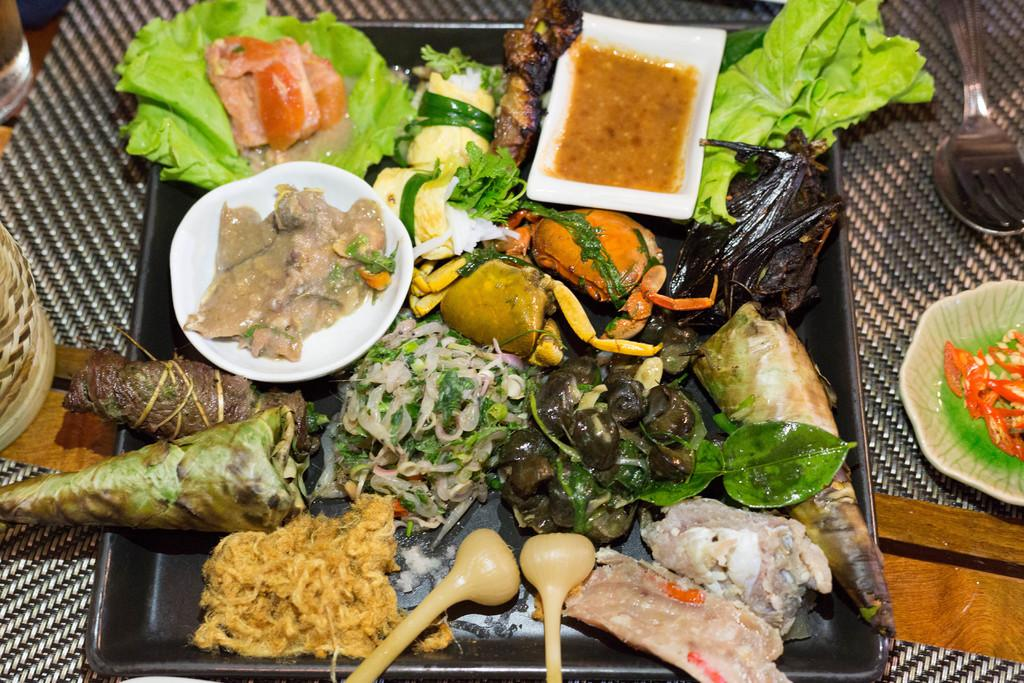What type of objects can be seen in the image? There are food items in the image. How are the food items arranged or contained? The food items are in a tray. What utensils are present in the image? There is a spoon and a fork in the image. Where are the spoon and fork located? The spoon and fork are on a table. What date is marked on the calendar in the image? There is no calendar present in the image; it only contains food items, a tray, and utensils. 